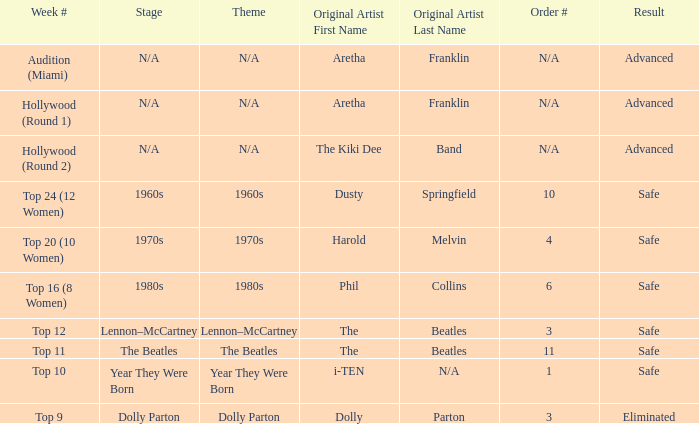What is the week number that has Dolly Parton as the theme? Top 9. 